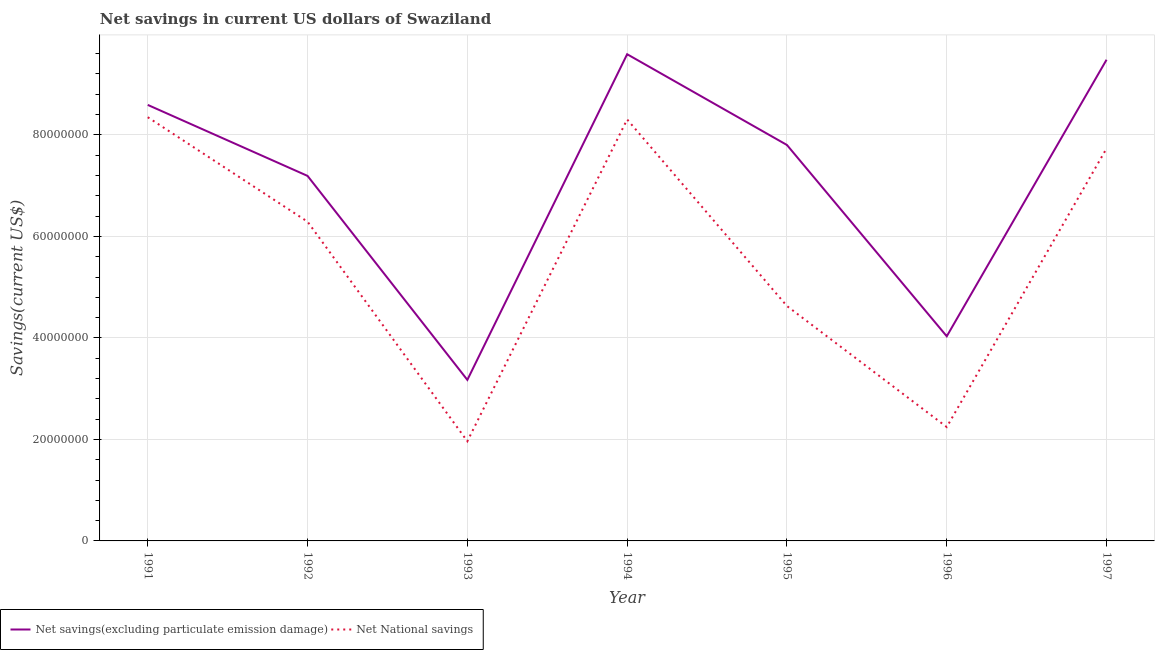Is the number of lines equal to the number of legend labels?
Your answer should be compact. Yes. What is the net savings(excluding particulate emission damage) in 1991?
Your response must be concise. 8.59e+07. Across all years, what is the maximum net national savings?
Keep it short and to the point. 8.35e+07. Across all years, what is the minimum net national savings?
Provide a short and direct response. 1.96e+07. In which year was the net savings(excluding particulate emission damage) maximum?
Provide a succinct answer. 1994. In which year was the net national savings minimum?
Offer a terse response. 1993. What is the total net national savings in the graph?
Your response must be concise. 3.95e+08. What is the difference between the net national savings in 1992 and that in 1993?
Offer a very short reply. 4.33e+07. What is the difference between the net savings(excluding particulate emission damage) in 1991 and the net national savings in 1993?
Ensure brevity in your answer.  6.63e+07. What is the average net national savings per year?
Your response must be concise. 5.64e+07. In the year 1991, what is the difference between the net savings(excluding particulate emission damage) and net national savings?
Make the answer very short. 2.43e+06. In how many years, is the net savings(excluding particulate emission damage) greater than 52000000 US$?
Provide a succinct answer. 5. What is the ratio of the net savings(excluding particulate emission damage) in 1991 to that in 1997?
Your answer should be very brief. 0.91. Is the net savings(excluding particulate emission damage) in 1994 less than that in 1997?
Keep it short and to the point. No. What is the difference between the highest and the second highest net savings(excluding particulate emission damage)?
Your answer should be very brief. 1.09e+06. What is the difference between the highest and the lowest net savings(excluding particulate emission damage)?
Your response must be concise. 6.42e+07. How many lines are there?
Your answer should be compact. 2. What is the difference between two consecutive major ticks on the Y-axis?
Ensure brevity in your answer.  2.00e+07. Are the values on the major ticks of Y-axis written in scientific E-notation?
Your answer should be very brief. No. Does the graph contain any zero values?
Give a very brief answer. No. Where does the legend appear in the graph?
Offer a terse response. Bottom left. What is the title of the graph?
Your answer should be very brief. Net savings in current US dollars of Swaziland. What is the label or title of the X-axis?
Your answer should be compact. Year. What is the label or title of the Y-axis?
Give a very brief answer. Savings(current US$). What is the Savings(current US$) of Net savings(excluding particulate emission damage) in 1991?
Offer a terse response. 8.59e+07. What is the Savings(current US$) of Net National savings in 1991?
Keep it short and to the point. 8.35e+07. What is the Savings(current US$) of Net savings(excluding particulate emission damage) in 1992?
Offer a terse response. 7.19e+07. What is the Savings(current US$) in Net National savings in 1992?
Make the answer very short. 6.29e+07. What is the Savings(current US$) of Net savings(excluding particulate emission damage) in 1993?
Offer a terse response. 3.17e+07. What is the Savings(current US$) in Net National savings in 1993?
Offer a very short reply. 1.96e+07. What is the Savings(current US$) of Net savings(excluding particulate emission damage) in 1994?
Provide a short and direct response. 9.59e+07. What is the Savings(current US$) in Net National savings in 1994?
Make the answer very short. 8.30e+07. What is the Savings(current US$) of Net savings(excluding particulate emission damage) in 1995?
Make the answer very short. 7.80e+07. What is the Savings(current US$) of Net National savings in 1995?
Your answer should be compact. 4.63e+07. What is the Savings(current US$) in Net savings(excluding particulate emission damage) in 1996?
Keep it short and to the point. 4.03e+07. What is the Savings(current US$) in Net National savings in 1996?
Offer a very short reply. 2.24e+07. What is the Savings(current US$) of Net savings(excluding particulate emission damage) in 1997?
Offer a very short reply. 9.48e+07. What is the Savings(current US$) of Net National savings in 1997?
Ensure brevity in your answer.  7.73e+07. Across all years, what is the maximum Savings(current US$) in Net savings(excluding particulate emission damage)?
Keep it short and to the point. 9.59e+07. Across all years, what is the maximum Savings(current US$) of Net National savings?
Ensure brevity in your answer.  8.35e+07. Across all years, what is the minimum Savings(current US$) in Net savings(excluding particulate emission damage)?
Your answer should be very brief. 3.17e+07. Across all years, what is the minimum Savings(current US$) of Net National savings?
Your answer should be compact. 1.96e+07. What is the total Savings(current US$) in Net savings(excluding particulate emission damage) in the graph?
Offer a very short reply. 4.99e+08. What is the total Savings(current US$) of Net National savings in the graph?
Your response must be concise. 3.95e+08. What is the difference between the Savings(current US$) in Net savings(excluding particulate emission damage) in 1991 and that in 1992?
Your answer should be compact. 1.40e+07. What is the difference between the Savings(current US$) of Net National savings in 1991 and that in 1992?
Your response must be concise. 2.06e+07. What is the difference between the Savings(current US$) in Net savings(excluding particulate emission damage) in 1991 and that in 1993?
Your response must be concise. 5.42e+07. What is the difference between the Savings(current US$) of Net National savings in 1991 and that in 1993?
Keep it short and to the point. 6.38e+07. What is the difference between the Savings(current US$) in Net savings(excluding particulate emission damage) in 1991 and that in 1994?
Offer a very short reply. -9.99e+06. What is the difference between the Savings(current US$) in Net National savings in 1991 and that in 1994?
Provide a short and direct response. 4.40e+05. What is the difference between the Savings(current US$) in Net savings(excluding particulate emission damage) in 1991 and that in 1995?
Keep it short and to the point. 7.90e+06. What is the difference between the Savings(current US$) of Net National savings in 1991 and that in 1995?
Your answer should be compact. 3.72e+07. What is the difference between the Savings(current US$) of Net savings(excluding particulate emission damage) in 1991 and that in 1996?
Provide a succinct answer. 4.56e+07. What is the difference between the Savings(current US$) of Net National savings in 1991 and that in 1996?
Ensure brevity in your answer.  6.10e+07. What is the difference between the Savings(current US$) in Net savings(excluding particulate emission damage) in 1991 and that in 1997?
Your response must be concise. -8.90e+06. What is the difference between the Savings(current US$) in Net National savings in 1991 and that in 1997?
Keep it short and to the point. 6.15e+06. What is the difference between the Savings(current US$) of Net savings(excluding particulate emission damage) in 1992 and that in 1993?
Give a very brief answer. 4.02e+07. What is the difference between the Savings(current US$) in Net National savings in 1992 and that in 1993?
Provide a short and direct response. 4.33e+07. What is the difference between the Savings(current US$) in Net savings(excluding particulate emission damage) in 1992 and that in 1994?
Give a very brief answer. -2.40e+07. What is the difference between the Savings(current US$) of Net National savings in 1992 and that in 1994?
Keep it short and to the point. -2.01e+07. What is the difference between the Savings(current US$) of Net savings(excluding particulate emission damage) in 1992 and that in 1995?
Make the answer very short. -6.09e+06. What is the difference between the Savings(current US$) of Net National savings in 1992 and that in 1995?
Your answer should be very brief. 1.66e+07. What is the difference between the Savings(current US$) of Net savings(excluding particulate emission damage) in 1992 and that in 1996?
Provide a short and direct response. 3.16e+07. What is the difference between the Savings(current US$) in Net National savings in 1992 and that in 1996?
Make the answer very short. 4.05e+07. What is the difference between the Savings(current US$) in Net savings(excluding particulate emission damage) in 1992 and that in 1997?
Your answer should be very brief. -2.29e+07. What is the difference between the Savings(current US$) in Net National savings in 1992 and that in 1997?
Offer a terse response. -1.44e+07. What is the difference between the Savings(current US$) in Net savings(excluding particulate emission damage) in 1993 and that in 1994?
Provide a short and direct response. -6.42e+07. What is the difference between the Savings(current US$) of Net National savings in 1993 and that in 1994?
Your response must be concise. -6.34e+07. What is the difference between the Savings(current US$) in Net savings(excluding particulate emission damage) in 1993 and that in 1995?
Your answer should be very brief. -4.63e+07. What is the difference between the Savings(current US$) in Net National savings in 1993 and that in 1995?
Your answer should be compact. -2.66e+07. What is the difference between the Savings(current US$) of Net savings(excluding particulate emission damage) in 1993 and that in 1996?
Provide a short and direct response. -8.59e+06. What is the difference between the Savings(current US$) in Net National savings in 1993 and that in 1996?
Offer a terse response. -2.80e+06. What is the difference between the Savings(current US$) in Net savings(excluding particulate emission damage) in 1993 and that in 1997?
Offer a terse response. -6.31e+07. What is the difference between the Savings(current US$) of Net National savings in 1993 and that in 1997?
Offer a very short reply. -5.77e+07. What is the difference between the Savings(current US$) in Net savings(excluding particulate emission damage) in 1994 and that in 1995?
Make the answer very short. 1.79e+07. What is the difference between the Savings(current US$) in Net National savings in 1994 and that in 1995?
Keep it short and to the point. 3.68e+07. What is the difference between the Savings(current US$) of Net savings(excluding particulate emission damage) in 1994 and that in 1996?
Ensure brevity in your answer.  5.56e+07. What is the difference between the Savings(current US$) of Net National savings in 1994 and that in 1996?
Give a very brief answer. 6.06e+07. What is the difference between the Savings(current US$) in Net savings(excluding particulate emission damage) in 1994 and that in 1997?
Your answer should be very brief. 1.09e+06. What is the difference between the Savings(current US$) in Net National savings in 1994 and that in 1997?
Your answer should be very brief. 5.71e+06. What is the difference between the Savings(current US$) of Net savings(excluding particulate emission damage) in 1995 and that in 1996?
Offer a terse response. 3.77e+07. What is the difference between the Savings(current US$) of Net National savings in 1995 and that in 1996?
Your answer should be compact. 2.38e+07. What is the difference between the Savings(current US$) of Net savings(excluding particulate emission damage) in 1995 and that in 1997?
Your answer should be very brief. -1.68e+07. What is the difference between the Savings(current US$) in Net National savings in 1995 and that in 1997?
Your answer should be compact. -3.10e+07. What is the difference between the Savings(current US$) in Net savings(excluding particulate emission damage) in 1996 and that in 1997?
Provide a short and direct response. -5.45e+07. What is the difference between the Savings(current US$) of Net National savings in 1996 and that in 1997?
Provide a short and direct response. -5.49e+07. What is the difference between the Savings(current US$) in Net savings(excluding particulate emission damage) in 1991 and the Savings(current US$) in Net National savings in 1992?
Ensure brevity in your answer.  2.30e+07. What is the difference between the Savings(current US$) of Net savings(excluding particulate emission damage) in 1991 and the Savings(current US$) of Net National savings in 1993?
Ensure brevity in your answer.  6.63e+07. What is the difference between the Savings(current US$) in Net savings(excluding particulate emission damage) in 1991 and the Savings(current US$) in Net National savings in 1994?
Provide a short and direct response. 2.87e+06. What is the difference between the Savings(current US$) in Net savings(excluding particulate emission damage) in 1991 and the Savings(current US$) in Net National savings in 1995?
Keep it short and to the point. 3.96e+07. What is the difference between the Savings(current US$) in Net savings(excluding particulate emission damage) in 1991 and the Savings(current US$) in Net National savings in 1996?
Provide a short and direct response. 6.35e+07. What is the difference between the Savings(current US$) of Net savings(excluding particulate emission damage) in 1991 and the Savings(current US$) of Net National savings in 1997?
Ensure brevity in your answer.  8.58e+06. What is the difference between the Savings(current US$) in Net savings(excluding particulate emission damage) in 1992 and the Savings(current US$) in Net National savings in 1993?
Your answer should be very brief. 5.23e+07. What is the difference between the Savings(current US$) in Net savings(excluding particulate emission damage) in 1992 and the Savings(current US$) in Net National savings in 1994?
Your response must be concise. -1.11e+07. What is the difference between the Savings(current US$) of Net savings(excluding particulate emission damage) in 1992 and the Savings(current US$) of Net National savings in 1995?
Offer a very short reply. 2.56e+07. What is the difference between the Savings(current US$) in Net savings(excluding particulate emission damage) in 1992 and the Savings(current US$) in Net National savings in 1996?
Provide a short and direct response. 4.95e+07. What is the difference between the Savings(current US$) of Net savings(excluding particulate emission damage) in 1992 and the Savings(current US$) of Net National savings in 1997?
Keep it short and to the point. -5.41e+06. What is the difference between the Savings(current US$) in Net savings(excluding particulate emission damage) in 1993 and the Savings(current US$) in Net National savings in 1994?
Provide a succinct answer. -5.13e+07. What is the difference between the Savings(current US$) in Net savings(excluding particulate emission damage) in 1993 and the Savings(current US$) in Net National savings in 1995?
Keep it short and to the point. -1.46e+07. What is the difference between the Savings(current US$) of Net savings(excluding particulate emission damage) in 1993 and the Savings(current US$) of Net National savings in 1996?
Your answer should be very brief. 9.29e+06. What is the difference between the Savings(current US$) in Net savings(excluding particulate emission damage) in 1993 and the Savings(current US$) in Net National savings in 1997?
Your answer should be compact. -4.56e+07. What is the difference between the Savings(current US$) in Net savings(excluding particulate emission damage) in 1994 and the Savings(current US$) in Net National savings in 1995?
Your response must be concise. 4.96e+07. What is the difference between the Savings(current US$) in Net savings(excluding particulate emission damage) in 1994 and the Savings(current US$) in Net National savings in 1996?
Offer a very short reply. 7.35e+07. What is the difference between the Savings(current US$) of Net savings(excluding particulate emission damage) in 1994 and the Savings(current US$) of Net National savings in 1997?
Give a very brief answer. 1.86e+07. What is the difference between the Savings(current US$) of Net savings(excluding particulate emission damage) in 1995 and the Savings(current US$) of Net National savings in 1996?
Keep it short and to the point. 5.56e+07. What is the difference between the Savings(current US$) in Net savings(excluding particulate emission damage) in 1995 and the Savings(current US$) in Net National savings in 1997?
Ensure brevity in your answer.  6.81e+05. What is the difference between the Savings(current US$) in Net savings(excluding particulate emission damage) in 1996 and the Savings(current US$) in Net National savings in 1997?
Offer a very short reply. -3.70e+07. What is the average Savings(current US$) of Net savings(excluding particulate emission damage) per year?
Keep it short and to the point. 7.12e+07. What is the average Savings(current US$) of Net National savings per year?
Make the answer very short. 5.64e+07. In the year 1991, what is the difference between the Savings(current US$) of Net savings(excluding particulate emission damage) and Savings(current US$) of Net National savings?
Provide a succinct answer. 2.43e+06. In the year 1992, what is the difference between the Savings(current US$) of Net savings(excluding particulate emission damage) and Savings(current US$) of Net National savings?
Make the answer very short. 9.02e+06. In the year 1993, what is the difference between the Savings(current US$) of Net savings(excluding particulate emission damage) and Savings(current US$) of Net National savings?
Give a very brief answer. 1.21e+07. In the year 1994, what is the difference between the Savings(current US$) in Net savings(excluding particulate emission damage) and Savings(current US$) in Net National savings?
Your answer should be very brief. 1.29e+07. In the year 1995, what is the difference between the Savings(current US$) in Net savings(excluding particulate emission damage) and Savings(current US$) in Net National savings?
Make the answer very short. 3.17e+07. In the year 1996, what is the difference between the Savings(current US$) of Net savings(excluding particulate emission damage) and Savings(current US$) of Net National savings?
Offer a very short reply. 1.79e+07. In the year 1997, what is the difference between the Savings(current US$) of Net savings(excluding particulate emission damage) and Savings(current US$) of Net National savings?
Provide a succinct answer. 1.75e+07. What is the ratio of the Savings(current US$) in Net savings(excluding particulate emission damage) in 1991 to that in 1992?
Give a very brief answer. 1.19. What is the ratio of the Savings(current US$) in Net National savings in 1991 to that in 1992?
Your answer should be compact. 1.33. What is the ratio of the Savings(current US$) of Net savings(excluding particulate emission damage) in 1991 to that in 1993?
Offer a terse response. 2.71. What is the ratio of the Savings(current US$) of Net National savings in 1991 to that in 1993?
Your answer should be compact. 4.25. What is the ratio of the Savings(current US$) in Net savings(excluding particulate emission damage) in 1991 to that in 1994?
Your answer should be compact. 0.9. What is the ratio of the Savings(current US$) in Net savings(excluding particulate emission damage) in 1991 to that in 1995?
Make the answer very short. 1.1. What is the ratio of the Savings(current US$) in Net National savings in 1991 to that in 1995?
Give a very brief answer. 1.8. What is the ratio of the Savings(current US$) in Net savings(excluding particulate emission damage) in 1991 to that in 1996?
Give a very brief answer. 2.13. What is the ratio of the Savings(current US$) of Net National savings in 1991 to that in 1996?
Offer a very short reply. 3.72. What is the ratio of the Savings(current US$) in Net savings(excluding particulate emission damage) in 1991 to that in 1997?
Your answer should be compact. 0.91. What is the ratio of the Savings(current US$) in Net National savings in 1991 to that in 1997?
Ensure brevity in your answer.  1.08. What is the ratio of the Savings(current US$) in Net savings(excluding particulate emission damage) in 1992 to that in 1993?
Your response must be concise. 2.27. What is the ratio of the Savings(current US$) of Net National savings in 1992 to that in 1993?
Provide a short and direct response. 3.2. What is the ratio of the Savings(current US$) of Net National savings in 1992 to that in 1994?
Make the answer very short. 0.76. What is the ratio of the Savings(current US$) in Net savings(excluding particulate emission damage) in 1992 to that in 1995?
Your answer should be compact. 0.92. What is the ratio of the Savings(current US$) in Net National savings in 1992 to that in 1995?
Offer a very short reply. 1.36. What is the ratio of the Savings(current US$) of Net savings(excluding particulate emission damage) in 1992 to that in 1996?
Ensure brevity in your answer.  1.78. What is the ratio of the Savings(current US$) of Net National savings in 1992 to that in 1996?
Ensure brevity in your answer.  2.8. What is the ratio of the Savings(current US$) in Net savings(excluding particulate emission damage) in 1992 to that in 1997?
Offer a very short reply. 0.76. What is the ratio of the Savings(current US$) in Net National savings in 1992 to that in 1997?
Your answer should be compact. 0.81. What is the ratio of the Savings(current US$) in Net savings(excluding particulate emission damage) in 1993 to that in 1994?
Offer a very short reply. 0.33. What is the ratio of the Savings(current US$) of Net National savings in 1993 to that in 1994?
Your answer should be compact. 0.24. What is the ratio of the Savings(current US$) of Net savings(excluding particulate emission damage) in 1993 to that in 1995?
Provide a short and direct response. 0.41. What is the ratio of the Savings(current US$) in Net National savings in 1993 to that in 1995?
Your answer should be compact. 0.42. What is the ratio of the Savings(current US$) of Net savings(excluding particulate emission damage) in 1993 to that in 1996?
Your response must be concise. 0.79. What is the ratio of the Savings(current US$) in Net National savings in 1993 to that in 1996?
Provide a succinct answer. 0.88. What is the ratio of the Savings(current US$) in Net savings(excluding particulate emission damage) in 1993 to that in 1997?
Offer a terse response. 0.33. What is the ratio of the Savings(current US$) in Net National savings in 1993 to that in 1997?
Ensure brevity in your answer.  0.25. What is the ratio of the Savings(current US$) in Net savings(excluding particulate emission damage) in 1994 to that in 1995?
Offer a very short reply. 1.23. What is the ratio of the Savings(current US$) of Net National savings in 1994 to that in 1995?
Give a very brief answer. 1.79. What is the ratio of the Savings(current US$) in Net savings(excluding particulate emission damage) in 1994 to that in 1996?
Your answer should be very brief. 2.38. What is the ratio of the Savings(current US$) of Net National savings in 1994 to that in 1996?
Your response must be concise. 3.7. What is the ratio of the Savings(current US$) of Net savings(excluding particulate emission damage) in 1994 to that in 1997?
Provide a succinct answer. 1.01. What is the ratio of the Savings(current US$) of Net National savings in 1994 to that in 1997?
Ensure brevity in your answer.  1.07. What is the ratio of the Savings(current US$) in Net savings(excluding particulate emission damage) in 1995 to that in 1996?
Your answer should be very brief. 1.93. What is the ratio of the Savings(current US$) of Net National savings in 1995 to that in 1996?
Your response must be concise. 2.06. What is the ratio of the Savings(current US$) of Net savings(excluding particulate emission damage) in 1995 to that in 1997?
Offer a terse response. 0.82. What is the ratio of the Savings(current US$) of Net National savings in 1995 to that in 1997?
Offer a terse response. 0.6. What is the ratio of the Savings(current US$) of Net savings(excluding particulate emission damage) in 1996 to that in 1997?
Provide a short and direct response. 0.43. What is the ratio of the Savings(current US$) in Net National savings in 1996 to that in 1997?
Provide a short and direct response. 0.29. What is the difference between the highest and the second highest Savings(current US$) in Net savings(excluding particulate emission damage)?
Provide a short and direct response. 1.09e+06. What is the difference between the highest and the second highest Savings(current US$) of Net National savings?
Provide a succinct answer. 4.40e+05. What is the difference between the highest and the lowest Savings(current US$) in Net savings(excluding particulate emission damage)?
Offer a terse response. 6.42e+07. What is the difference between the highest and the lowest Savings(current US$) of Net National savings?
Your answer should be very brief. 6.38e+07. 